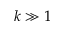<formula> <loc_0><loc_0><loc_500><loc_500>k \gg 1</formula> 